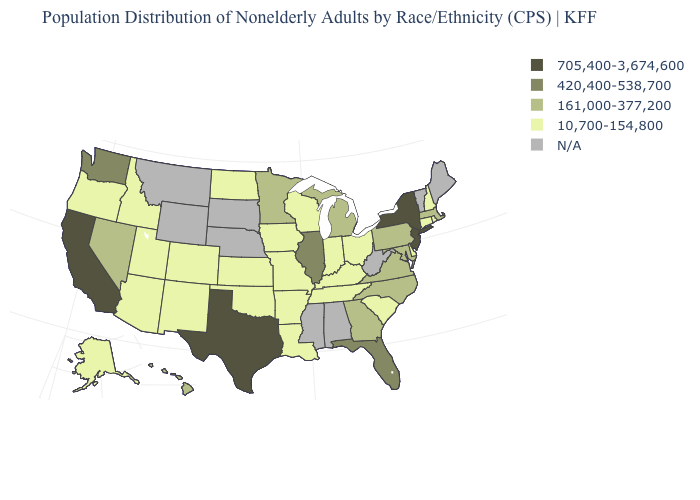What is the lowest value in the MidWest?
Give a very brief answer. 10,700-154,800. Name the states that have a value in the range 161,000-377,200?
Short answer required. Georgia, Hawaii, Maryland, Massachusetts, Michigan, Minnesota, Nevada, North Carolina, Pennsylvania, Virginia. Which states have the lowest value in the USA?
Give a very brief answer. Alaska, Arizona, Arkansas, Colorado, Connecticut, Delaware, Idaho, Indiana, Iowa, Kansas, Kentucky, Louisiana, Missouri, New Hampshire, New Mexico, North Dakota, Ohio, Oklahoma, Oregon, Rhode Island, South Carolina, Tennessee, Utah, Wisconsin. What is the value of North Dakota?
Give a very brief answer. 10,700-154,800. What is the value of Arizona?
Answer briefly. 10,700-154,800. Among the states that border Nebraska , which have the highest value?
Quick response, please. Colorado, Iowa, Kansas, Missouri. Name the states that have a value in the range 161,000-377,200?
Give a very brief answer. Georgia, Hawaii, Maryland, Massachusetts, Michigan, Minnesota, Nevada, North Carolina, Pennsylvania, Virginia. What is the lowest value in the USA?
Be succinct. 10,700-154,800. Which states have the lowest value in the USA?
Answer briefly. Alaska, Arizona, Arkansas, Colorado, Connecticut, Delaware, Idaho, Indiana, Iowa, Kansas, Kentucky, Louisiana, Missouri, New Hampshire, New Mexico, North Dakota, Ohio, Oklahoma, Oregon, Rhode Island, South Carolina, Tennessee, Utah, Wisconsin. Name the states that have a value in the range 420,400-538,700?
Be succinct. Florida, Illinois, Washington. Name the states that have a value in the range 420,400-538,700?
Give a very brief answer. Florida, Illinois, Washington. Name the states that have a value in the range 420,400-538,700?
Short answer required. Florida, Illinois, Washington. How many symbols are there in the legend?
Be succinct. 5. Name the states that have a value in the range 420,400-538,700?
Keep it brief. Florida, Illinois, Washington. 